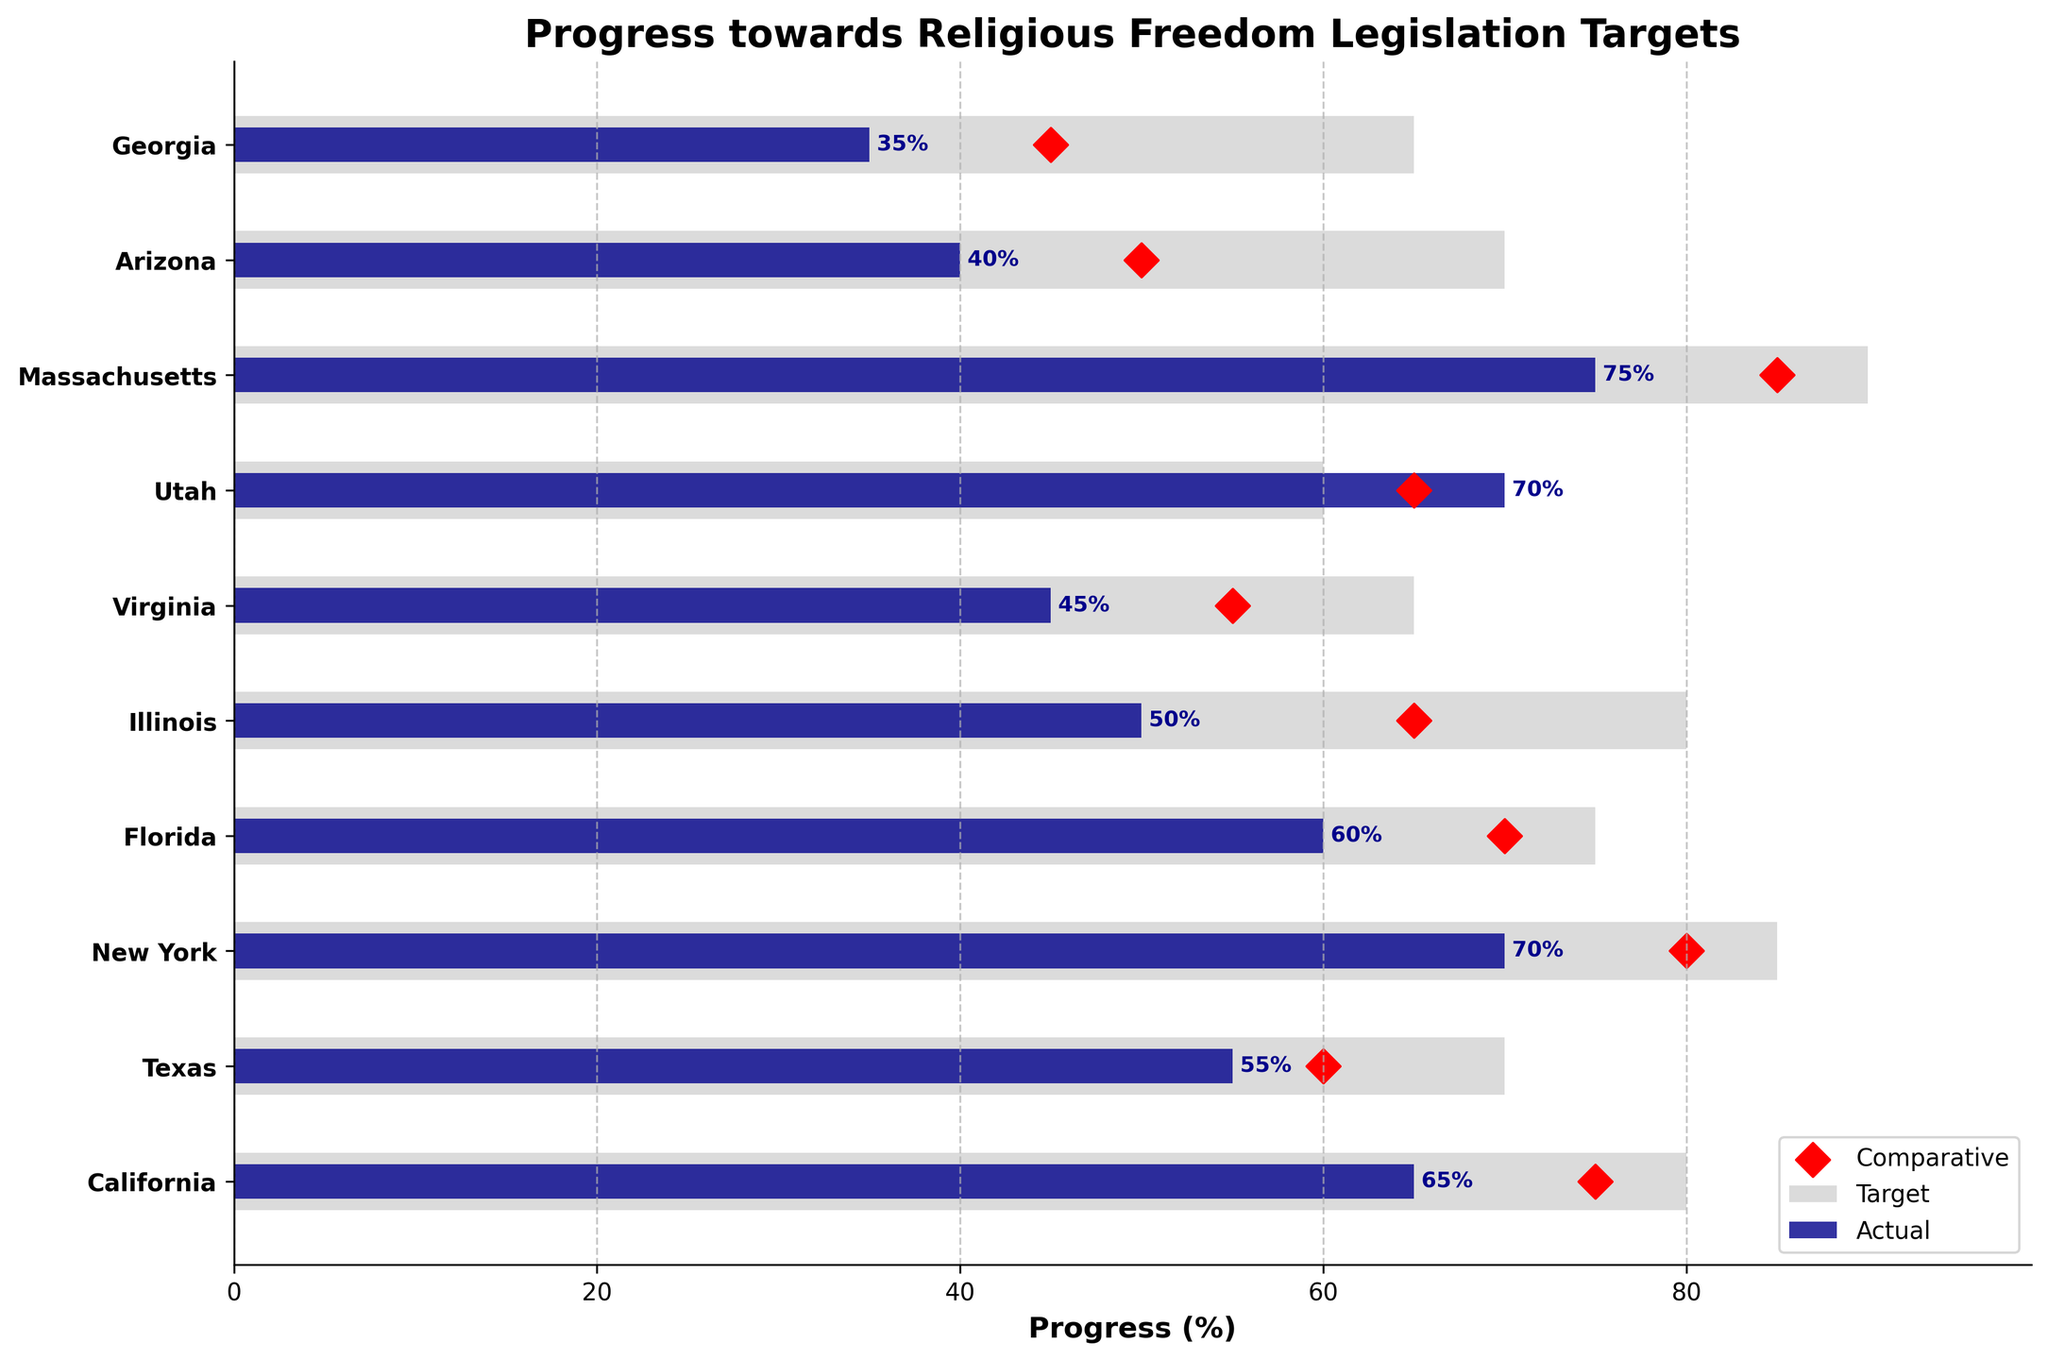What's the title of the chart? The title is usually placed on top of the chart, and in this case, it reads "Progress towards Religious Freedom Legislation Targets".
Answer: Progress towards Religious Freedom Legislation Targets How many states are represented in the chart? By counting the number of bars and y-tick labels on the chart, you can determine the number of states. There are 10 states listed.
Answer: 10 Which state has the highest actual progress percentage? Look at the height of the dark blue bars (representing actual progress). Massachusetts has the highest actual progress percentage at 75%.
Answer: Massachusetts Which state has surpassed its target for religious freedom legislation? Identify states where the actual bar (dark blue) exceeds the target bar (light gray). Utah has an actual progress of 70%, which surpasses its target of 60%.
Answer: Utah How does California's actual progress compare to its comparative value? Check the actual progress bar (dark blue) and the red diamond marker for California. The actual progress is 65%, while the comparative value is 75%.
Answer: 65% vs 75% Which state has the greatest difference between its target and actual progress? Calculate the difference between the target and actual progress columns for each state and compare. Illinois has the greatest difference, with a target of 80 and actual progress of 50, resulting in a difference of 30.
Answer: Illinois What is the average target percentage across all states? Sum all target values and divide by the number of states. The sum of targets is 80 + 70 + 85 + 75 + 80 + 65 + 60 + 90 + 70 + 65 = 740. Divide by 10 states: 740 / 10 = 74%.
Answer: 74% Which state is furthest behind on achieving its target in terms of absolute percentage points? Determine the gap between target and actual for each state. The state with the largest gap is Georgia, with a target of 65 and actual progress of 35, a difference of 30 percentage points.
Answer: Georgia What is the actual progress value for Virginia, and how does it compare to the comparative value for Virginia? Look at the dark blue bar and red diamond marker for Virginia. The actual progress is 45%, and the comparative value is 55%.
Answer: 45% actual, 55% comparative How many states have actual progress percentages below their comparative values? Compare the dark blue bars (actual) to the red diamonds (comparative). For California, Texas, New York, Florida, Illinois, Virginia, and Arizona, the actual progress is below their comparative values. There are 7 such states.
Answer: 7 states 